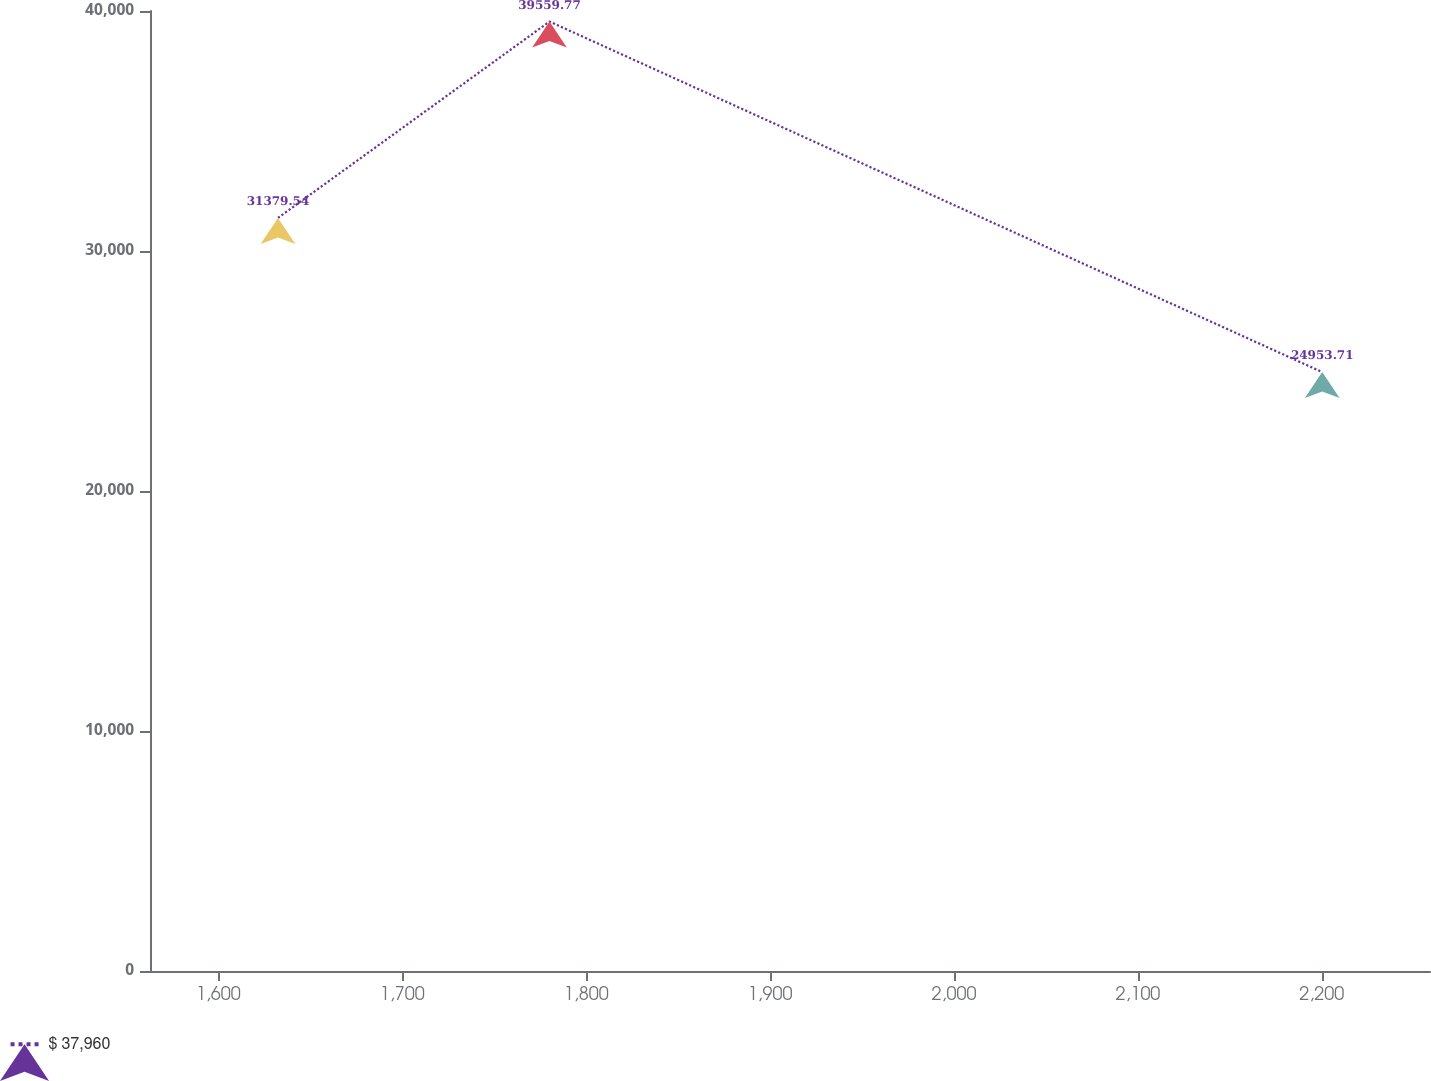Convert chart to OTSL. <chart><loc_0><loc_0><loc_500><loc_500><line_chart><ecel><fcel>$ 37,960<nl><fcel>1632.44<fcel>31379.5<nl><fcel>1780.06<fcel>39559.8<nl><fcel>2200.23<fcel>24953.7<nl><fcel>2328.43<fcel>23330.8<nl></chart> 